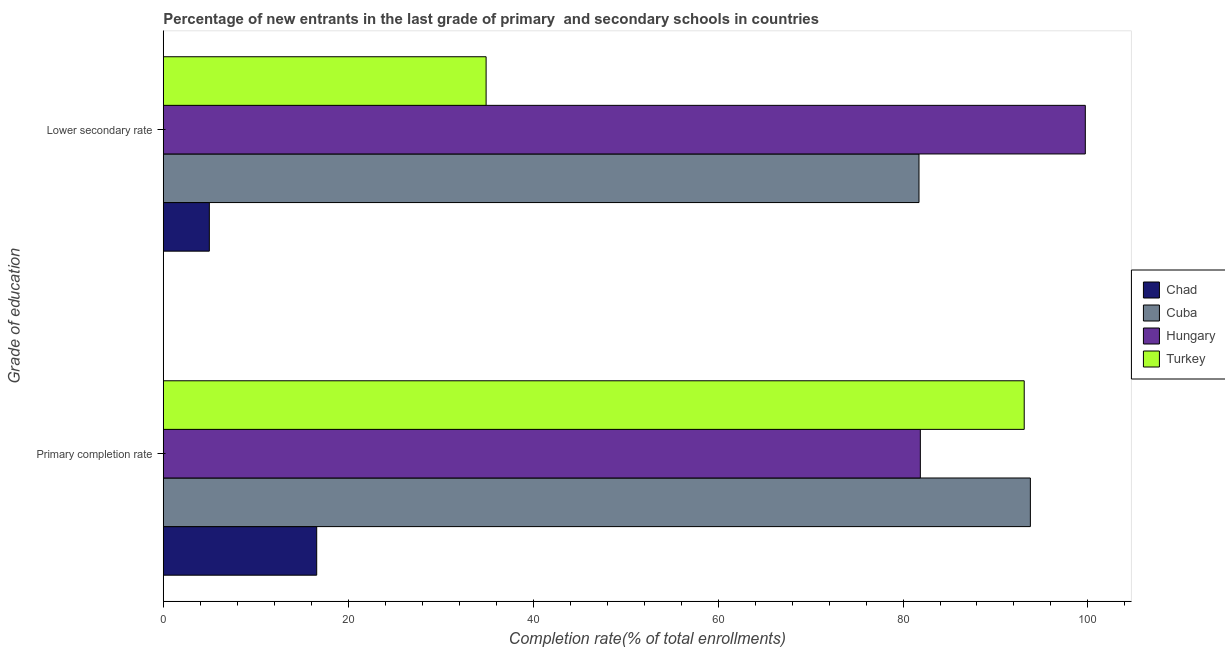Are the number of bars per tick equal to the number of legend labels?
Your answer should be compact. Yes. Are the number of bars on each tick of the Y-axis equal?
Your answer should be very brief. Yes. What is the label of the 2nd group of bars from the top?
Keep it short and to the point. Primary completion rate. What is the completion rate in secondary schools in Cuba?
Provide a short and direct response. 81.73. Across all countries, what is the maximum completion rate in primary schools?
Your answer should be very brief. 93.77. Across all countries, what is the minimum completion rate in secondary schools?
Make the answer very short. 4.98. In which country was the completion rate in primary schools maximum?
Your answer should be very brief. Cuba. In which country was the completion rate in primary schools minimum?
Offer a terse response. Chad. What is the total completion rate in secondary schools in the graph?
Provide a succinct answer. 221.34. What is the difference between the completion rate in primary schools in Chad and that in Cuba?
Offer a very short reply. -77.18. What is the difference between the completion rate in primary schools in Turkey and the completion rate in secondary schools in Cuba?
Give a very brief answer. 11.38. What is the average completion rate in secondary schools per country?
Offer a very short reply. 55.34. What is the difference between the completion rate in primary schools and completion rate in secondary schools in Chad?
Offer a very short reply. 11.61. In how many countries, is the completion rate in primary schools greater than 92 %?
Give a very brief answer. 2. What is the ratio of the completion rate in primary schools in Cuba to that in Turkey?
Keep it short and to the point. 1.01. Is the completion rate in secondary schools in Hungary less than that in Cuba?
Your answer should be compact. No. What does the 4th bar from the top in Primary completion rate represents?
Keep it short and to the point. Chad. What does the 4th bar from the bottom in Primary completion rate represents?
Give a very brief answer. Turkey. How many bars are there?
Your answer should be compact. 8. Are all the bars in the graph horizontal?
Your response must be concise. Yes. What is the difference between two consecutive major ticks on the X-axis?
Offer a very short reply. 20. Are the values on the major ticks of X-axis written in scientific E-notation?
Offer a very short reply. No. Does the graph contain grids?
Your response must be concise. No. Where does the legend appear in the graph?
Your answer should be compact. Center right. How many legend labels are there?
Give a very brief answer. 4. How are the legend labels stacked?
Offer a terse response. Vertical. What is the title of the graph?
Keep it short and to the point. Percentage of new entrants in the last grade of primary  and secondary schools in countries. Does "Central African Republic" appear as one of the legend labels in the graph?
Your answer should be very brief. No. What is the label or title of the X-axis?
Your answer should be very brief. Completion rate(% of total enrollments). What is the label or title of the Y-axis?
Your response must be concise. Grade of education. What is the Completion rate(% of total enrollments) of Chad in Primary completion rate?
Offer a very short reply. 16.59. What is the Completion rate(% of total enrollments) in Cuba in Primary completion rate?
Offer a terse response. 93.77. What is the Completion rate(% of total enrollments) of Hungary in Primary completion rate?
Your answer should be very brief. 81.87. What is the Completion rate(% of total enrollments) of Turkey in Primary completion rate?
Provide a short and direct response. 93.11. What is the Completion rate(% of total enrollments) of Chad in Lower secondary rate?
Your answer should be compact. 4.98. What is the Completion rate(% of total enrollments) in Cuba in Lower secondary rate?
Provide a succinct answer. 81.73. What is the Completion rate(% of total enrollments) of Hungary in Lower secondary rate?
Provide a succinct answer. 99.72. What is the Completion rate(% of total enrollments) of Turkey in Lower secondary rate?
Make the answer very short. 34.91. Across all Grade of education, what is the maximum Completion rate(% of total enrollments) of Chad?
Your answer should be very brief. 16.59. Across all Grade of education, what is the maximum Completion rate(% of total enrollments) of Cuba?
Ensure brevity in your answer.  93.77. Across all Grade of education, what is the maximum Completion rate(% of total enrollments) of Hungary?
Your response must be concise. 99.72. Across all Grade of education, what is the maximum Completion rate(% of total enrollments) of Turkey?
Ensure brevity in your answer.  93.11. Across all Grade of education, what is the minimum Completion rate(% of total enrollments) in Chad?
Your answer should be very brief. 4.98. Across all Grade of education, what is the minimum Completion rate(% of total enrollments) of Cuba?
Make the answer very short. 81.73. Across all Grade of education, what is the minimum Completion rate(% of total enrollments) in Hungary?
Offer a very short reply. 81.87. Across all Grade of education, what is the minimum Completion rate(% of total enrollments) in Turkey?
Provide a short and direct response. 34.91. What is the total Completion rate(% of total enrollments) in Chad in the graph?
Your answer should be very brief. 21.58. What is the total Completion rate(% of total enrollments) in Cuba in the graph?
Make the answer very short. 175.5. What is the total Completion rate(% of total enrollments) in Hungary in the graph?
Make the answer very short. 181.59. What is the total Completion rate(% of total enrollments) in Turkey in the graph?
Ensure brevity in your answer.  128.02. What is the difference between the Completion rate(% of total enrollments) of Chad in Primary completion rate and that in Lower secondary rate?
Offer a terse response. 11.61. What is the difference between the Completion rate(% of total enrollments) in Cuba in Primary completion rate and that in Lower secondary rate?
Offer a very short reply. 12.04. What is the difference between the Completion rate(% of total enrollments) in Hungary in Primary completion rate and that in Lower secondary rate?
Offer a very short reply. -17.84. What is the difference between the Completion rate(% of total enrollments) of Turkey in Primary completion rate and that in Lower secondary rate?
Provide a succinct answer. 58.19. What is the difference between the Completion rate(% of total enrollments) in Chad in Primary completion rate and the Completion rate(% of total enrollments) in Cuba in Lower secondary rate?
Keep it short and to the point. -65.14. What is the difference between the Completion rate(% of total enrollments) in Chad in Primary completion rate and the Completion rate(% of total enrollments) in Hungary in Lower secondary rate?
Keep it short and to the point. -83.12. What is the difference between the Completion rate(% of total enrollments) of Chad in Primary completion rate and the Completion rate(% of total enrollments) of Turkey in Lower secondary rate?
Make the answer very short. -18.32. What is the difference between the Completion rate(% of total enrollments) of Cuba in Primary completion rate and the Completion rate(% of total enrollments) of Hungary in Lower secondary rate?
Provide a short and direct response. -5.94. What is the difference between the Completion rate(% of total enrollments) of Cuba in Primary completion rate and the Completion rate(% of total enrollments) of Turkey in Lower secondary rate?
Your answer should be compact. 58.86. What is the difference between the Completion rate(% of total enrollments) in Hungary in Primary completion rate and the Completion rate(% of total enrollments) in Turkey in Lower secondary rate?
Your answer should be compact. 46.96. What is the average Completion rate(% of total enrollments) of Chad per Grade of education?
Provide a succinct answer. 10.79. What is the average Completion rate(% of total enrollments) of Cuba per Grade of education?
Give a very brief answer. 87.75. What is the average Completion rate(% of total enrollments) in Hungary per Grade of education?
Your response must be concise. 90.79. What is the average Completion rate(% of total enrollments) of Turkey per Grade of education?
Your answer should be very brief. 64.01. What is the difference between the Completion rate(% of total enrollments) in Chad and Completion rate(% of total enrollments) in Cuba in Primary completion rate?
Give a very brief answer. -77.18. What is the difference between the Completion rate(% of total enrollments) of Chad and Completion rate(% of total enrollments) of Hungary in Primary completion rate?
Your response must be concise. -65.28. What is the difference between the Completion rate(% of total enrollments) of Chad and Completion rate(% of total enrollments) of Turkey in Primary completion rate?
Make the answer very short. -76.51. What is the difference between the Completion rate(% of total enrollments) of Cuba and Completion rate(% of total enrollments) of Hungary in Primary completion rate?
Your answer should be very brief. 11.9. What is the difference between the Completion rate(% of total enrollments) of Cuba and Completion rate(% of total enrollments) of Turkey in Primary completion rate?
Your answer should be very brief. 0.67. What is the difference between the Completion rate(% of total enrollments) of Hungary and Completion rate(% of total enrollments) of Turkey in Primary completion rate?
Give a very brief answer. -11.23. What is the difference between the Completion rate(% of total enrollments) in Chad and Completion rate(% of total enrollments) in Cuba in Lower secondary rate?
Your answer should be compact. -76.75. What is the difference between the Completion rate(% of total enrollments) of Chad and Completion rate(% of total enrollments) of Hungary in Lower secondary rate?
Ensure brevity in your answer.  -94.73. What is the difference between the Completion rate(% of total enrollments) in Chad and Completion rate(% of total enrollments) in Turkey in Lower secondary rate?
Provide a succinct answer. -29.93. What is the difference between the Completion rate(% of total enrollments) of Cuba and Completion rate(% of total enrollments) of Hungary in Lower secondary rate?
Offer a very short reply. -17.99. What is the difference between the Completion rate(% of total enrollments) in Cuba and Completion rate(% of total enrollments) in Turkey in Lower secondary rate?
Offer a terse response. 46.82. What is the difference between the Completion rate(% of total enrollments) in Hungary and Completion rate(% of total enrollments) in Turkey in Lower secondary rate?
Offer a terse response. 64.8. What is the ratio of the Completion rate(% of total enrollments) of Chad in Primary completion rate to that in Lower secondary rate?
Offer a very short reply. 3.33. What is the ratio of the Completion rate(% of total enrollments) of Cuba in Primary completion rate to that in Lower secondary rate?
Give a very brief answer. 1.15. What is the ratio of the Completion rate(% of total enrollments) of Hungary in Primary completion rate to that in Lower secondary rate?
Offer a terse response. 0.82. What is the ratio of the Completion rate(% of total enrollments) in Turkey in Primary completion rate to that in Lower secondary rate?
Offer a terse response. 2.67. What is the difference between the highest and the second highest Completion rate(% of total enrollments) in Chad?
Offer a terse response. 11.61. What is the difference between the highest and the second highest Completion rate(% of total enrollments) of Cuba?
Make the answer very short. 12.04. What is the difference between the highest and the second highest Completion rate(% of total enrollments) of Hungary?
Your response must be concise. 17.84. What is the difference between the highest and the second highest Completion rate(% of total enrollments) in Turkey?
Your response must be concise. 58.19. What is the difference between the highest and the lowest Completion rate(% of total enrollments) in Chad?
Offer a very short reply. 11.61. What is the difference between the highest and the lowest Completion rate(% of total enrollments) of Cuba?
Ensure brevity in your answer.  12.04. What is the difference between the highest and the lowest Completion rate(% of total enrollments) of Hungary?
Make the answer very short. 17.84. What is the difference between the highest and the lowest Completion rate(% of total enrollments) in Turkey?
Offer a very short reply. 58.19. 